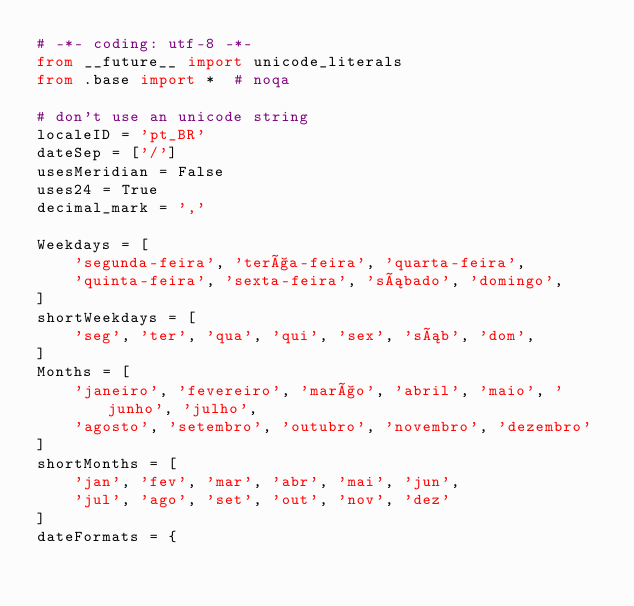<code> <loc_0><loc_0><loc_500><loc_500><_Python_># -*- coding: utf-8 -*-
from __future__ import unicode_literals
from .base import *  # noqa

# don't use an unicode string
localeID = 'pt_BR'
dateSep = ['/']
usesMeridian = False
uses24 = True
decimal_mark = ','

Weekdays = [
    'segunda-feira', 'terça-feira', 'quarta-feira',
    'quinta-feira', 'sexta-feira', 'sábado', 'domingo',
]
shortWeekdays = [
    'seg', 'ter', 'qua', 'qui', 'sex', 'sáb', 'dom',
]
Months = [
    'janeiro', 'fevereiro', 'março', 'abril', 'maio', 'junho', 'julho',
    'agosto', 'setembro', 'outubro', 'novembro', 'dezembro'
]
shortMonths = [
    'jan', 'fev', 'mar', 'abr', 'mai', 'jun',
    'jul', 'ago', 'set', 'out', 'nov', 'dez'
]
dateFormats = {</code> 